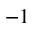Convert formula to latex. <formula><loc_0><loc_0><loc_500><loc_500>- 1</formula> 